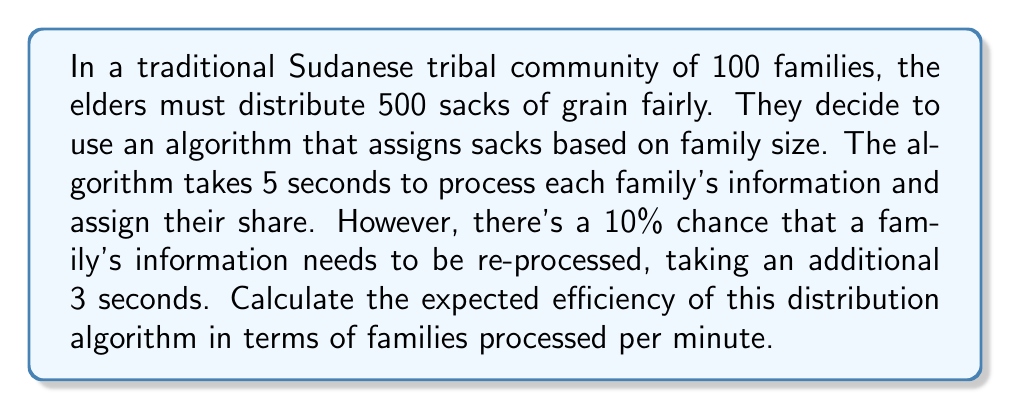Help me with this question. To solve this problem, we need to follow these steps:

1) First, let's calculate the expected time to process one family:
   Base time: 5 seconds
   Probability of re-processing: 10% = 0.1
   Time for re-processing: 3 seconds
   
   Expected time = Base time + (Probability of re-processing × Re-processing time)
   $$E(t) = 5 + (0.1 \times 3) = 5.3$$ seconds

2) Now, let's calculate how many families can be processed in one minute:
   One minute = 60 seconds
   
   Number of families processed = Time available / Expected time per family
   $$N = \frac{60}{5.3} \approx 11.32$$ families per minute

3) The efficiency of the algorithm is typically expressed as an integer, so we round down to the nearest whole number.
Answer: The expected efficiency of the distribution algorithm is 11 families processed per minute. 